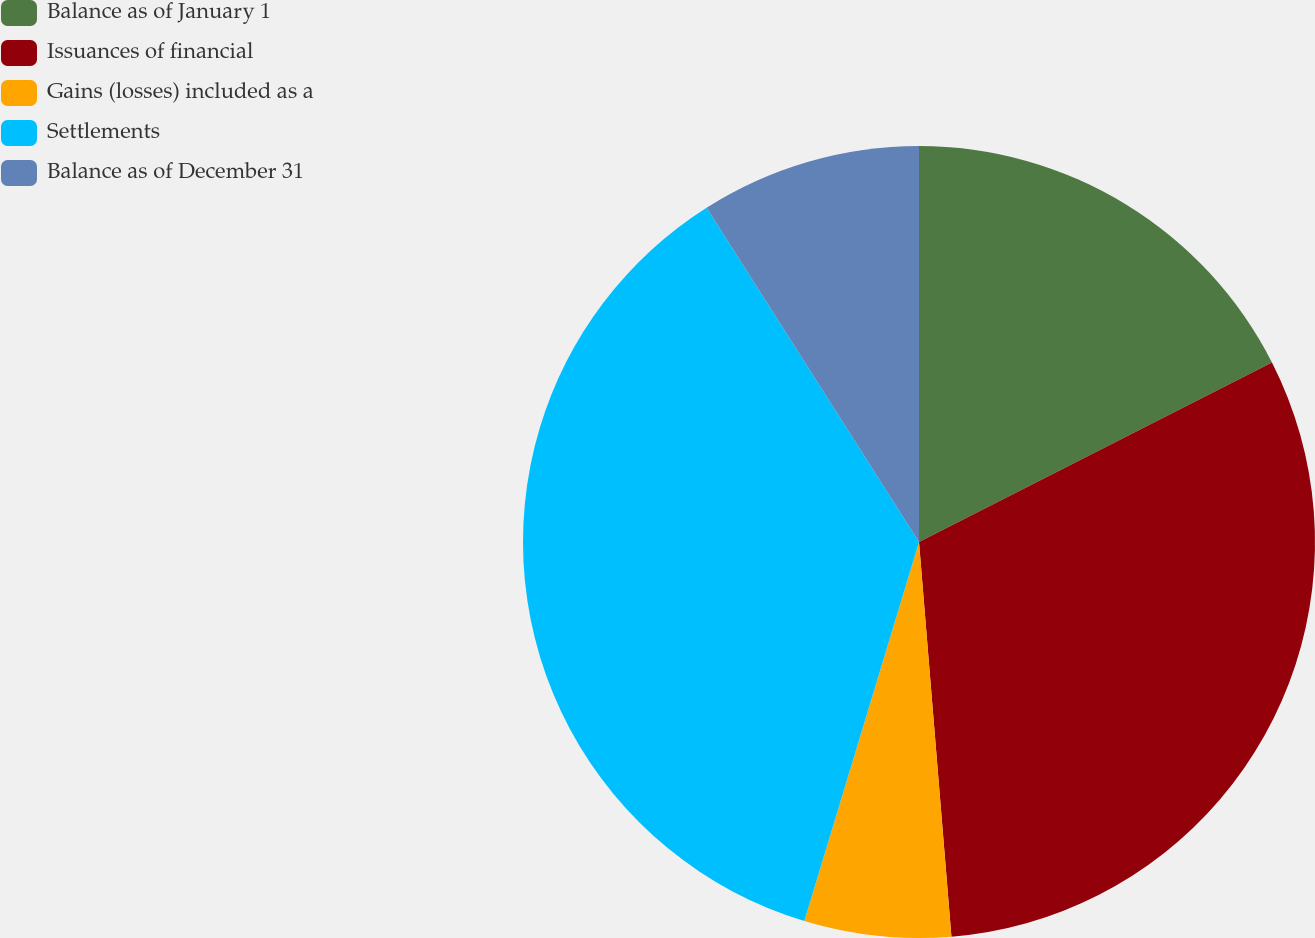<chart> <loc_0><loc_0><loc_500><loc_500><pie_chart><fcel>Balance as of January 1<fcel>Issuances of financial<fcel>Gains (losses) included as a<fcel>Settlements<fcel>Balance as of December 31<nl><fcel>17.51%<fcel>31.18%<fcel>5.98%<fcel>36.31%<fcel>9.01%<nl></chart> 